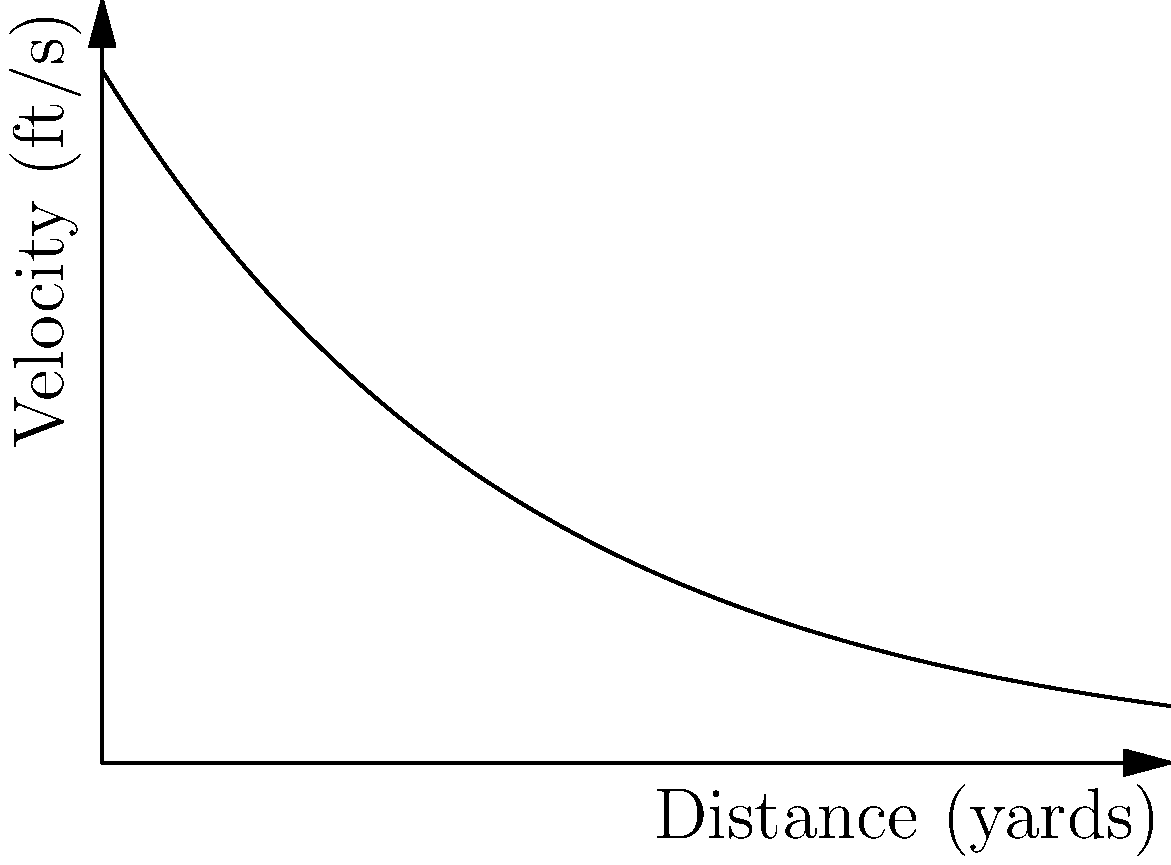A .308 Winchester rifle's bullet velocity decreases exponentially with distance, as shown in the graph. The initial velocity is 1000 ft/s, and the velocity at 100 yards is 950 ft/s. If the minimum effective velocity is 700 ft/s, what is the approximate effective range of this rifle in yards? To solve this problem, we need to follow these steps:

1) First, we need to determine the exponential decay function for velocity:
   $v(x) = v_0 e^{-kx}$
   where $v_0$ is the initial velocity, $k$ is the decay constant, and $x$ is the distance.

2) We know that $v_0 = 1000$ ft/s and $v(100) = 950$ ft/s. Let's use these to find $k$:
   $950 = 1000 e^{-100k}$
   $0.95 = e^{-100k}$
   $\ln(0.95) = -100k$
   $k = -\frac{\ln(0.95)}{100} \approx 0.000513$

3) Now our velocity function is:
   $v(x) = 1000 e^{-0.000513x}$

4) To find the effective range, we need to solve:
   $700 = 1000 e^{-0.000513x}$

5) Dividing both sides by 1000:
   $0.7 = e^{-0.000513x}$

6) Taking the natural log of both sides:
   $\ln(0.7) = -0.000513x$

7) Solving for $x$:
   $x = -\frac{\ln(0.7)}{0.000513} \approx 691$ yards

Therefore, the approximate effective range is 691 yards.
Answer: 691 yards 